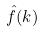Convert formula to latex. <formula><loc_0><loc_0><loc_500><loc_500>\hat { f } ( k )</formula> 